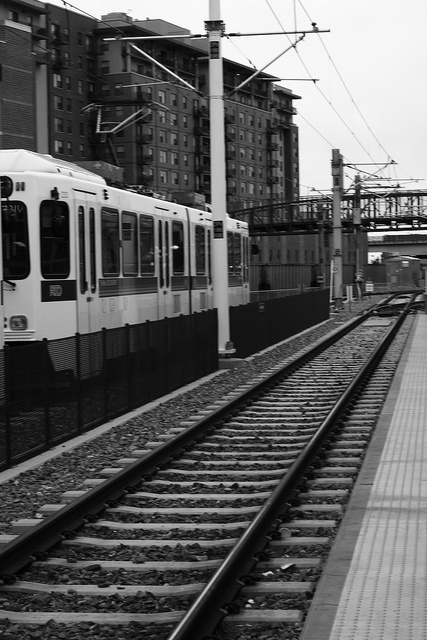Describe the objects in this image and their specific colors. I can see a train in black, darkgray, gray, and lightgray tones in this image. 